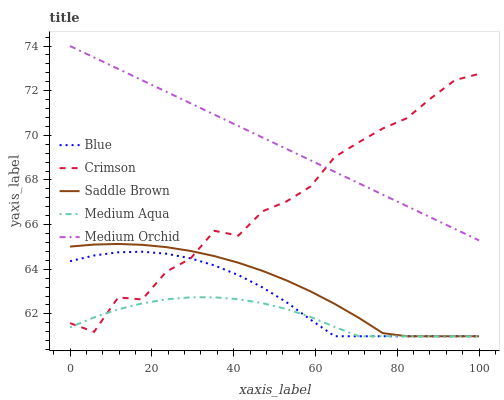Does Crimson have the minimum area under the curve?
Answer yes or no. No. Does Crimson have the maximum area under the curve?
Answer yes or no. No. Is Crimson the smoothest?
Answer yes or no. No. Is Medium Orchid the roughest?
Answer yes or no. No. Does Crimson have the lowest value?
Answer yes or no. No. Does Crimson have the highest value?
Answer yes or no. No. Is Saddle Brown less than Medium Orchid?
Answer yes or no. Yes. Is Medium Orchid greater than Saddle Brown?
Answer yes or no. Yes. Does Saddle Brown intersect Medium Orchid?
Answer yes or no. No. 